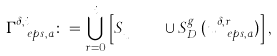<formula> <loc_0><loc_0><loc_500><loc_500>\Gamma ^ { \delta , i } _ { \ e p s , a } \colon = \bigcup _ { r = 0 } ^ { i } \left [ S _ { u ^ { \delta , r } _ { \ e p s , a } } \cup S _ { D } ^ { g ^ { \delta } _ { r } } ( u ^ { \delta , r } _ { \ e p s , a } ) \right ] ,</formula> 